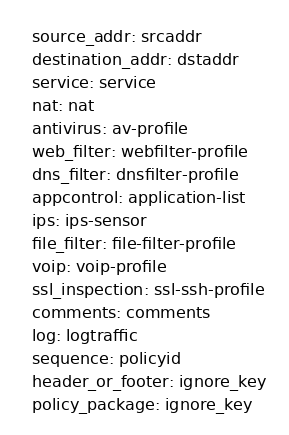<code> <loc_0><loc_0><loc_500><loc_500><_YAML_>  source_addr: srcaddr
  destination_addr: dstaddr
  service: service
  nat: nat
  antivirus: av-profile
  web_filter: webfilter-profile
  dns_filter: dnsfilter-profile
  appcontrol: application-list
  ips: ips-sensor
  file_filter: file-filter-profile
  voip: voip-profile
  ssl_inspection: ssl-ssh-profile
  comments: comments
  log: logtraffic
  sequence: policyid
  header_or_footer: ignore_key
  policy_package: ignore_key</code> 